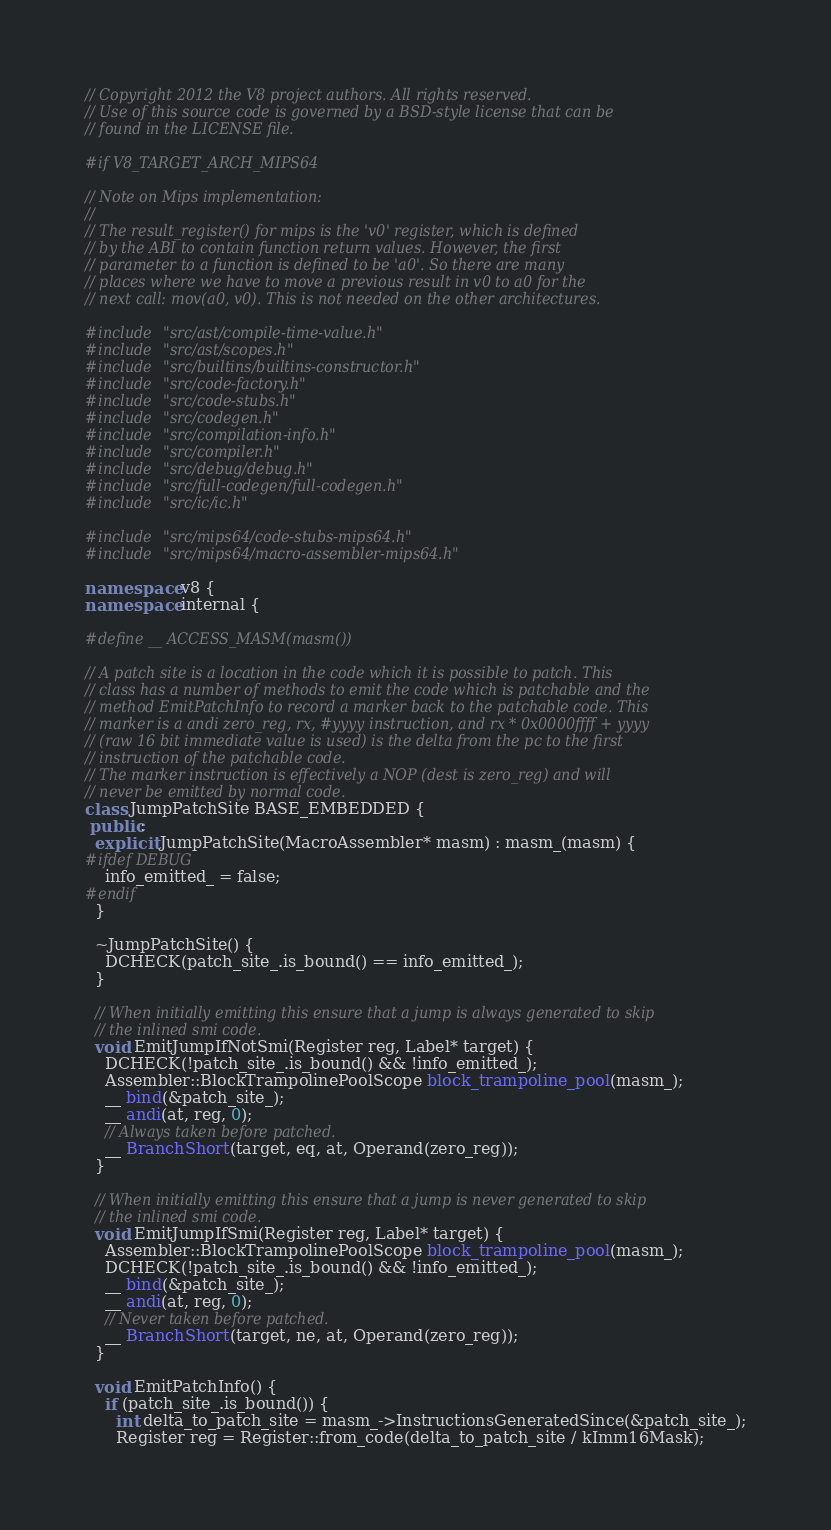Convert code to text. <code><loc_0><loc_0><loc_500><loc_500><_C++_>// Copyright 2012 the V8 project authors. All rights reserved.
// Use of this source code is governed by a BSD-style license that can be
// found in the LICENSE file.

#if V8_TARGET_ARCH_MIPS64

// Note on Mips implementation:
//
// The result_register() for mips is the 'v0' register, which is defined
// by the ABI to contain function return values. However, the first
// parameter to a function is defined to be 'a0'. So there are many
// places where we have to move a previous result in v0 to a0 for the
// next call: mov(a0, v0). This is not needed on the other architectures.

#include "src/ast/compile-time-value.h"
#include "src/ast/scopes.h"
#include "src/builtins/builtins-constructor.h"
#include "src/code-factory.h"
#include "src/code-stubs.h"
#include "src/codegen.h"
#include "src/compilation-info.h"
#include "src/compiler.h"
#include "src/debug/debug.h"
#include "src/full-codegen/full-codegen.h"
#include "src/ic/ic.h"

#include "src/mips64/code-stubs-mips64.h"
#include "src/mips64/macro-assembler-mips64.h"

namespace v8 {
namespace internal {

#define __ ACCESS_MASM(masm())

// A patch site is a location in the code which it is possible to patch. This
// class has a number of methods to emit the code which is patchable and the
// method EmitPatchInfo to record a marker back to the patchable code. This
// marker is a andi zero_reg, rx, #yyyy instruction, and rx * 0x0000ffff + yyyy
// (raw 16 bit immediate value is used) is the delta from the pc to the first
// instruction of the patchable code.
// The marker instruction is effectively a NOP (dest is zero_reg) and will
// never be emitted by normal code.
class JumpPatchSite BASE_EMBEDDED {
 public:
  explicit JumpPatchSite(MacroAssembler* masm) : masm_(masm) {
#ifdef DEBUG
    info_emitted_ = false;
#endif
  }

  ~JumpPatchSite() {
    DCHECK(patch_site_.is_bound() == info_emitted_);
  }

  // When initially emitting this ensure that a jump is always generated to skip
  // the inlined smi code.
  void EmitJumpIfNotSmi(Register reg, Label* target) {
    DCHECK(!patch_site_.is_bound() && !info_emitted_);
    Assembler::BlockTrampolinePoolScope block_trampoline_pool(masm_);
    __ bind(&patch_site_);
    __ andi(at, reg, 0);
    // Always taken before patched.
    __ BranchShort(target, eq, at, Operand(zero_reg));
  }

  // When initially emitting this ensure that a jump is never generated to skip
  // the inlined smi code.
  void EmitJumpIfSmi(Register reg, Label* target) {
    Assembler::BlockTrampolinePoolScope block_trampoline_pool(masm_);
    DCHECK(!patch_site_.is_bound() && !info_emitted_);
    __ bind(&patch_site_);
    __ andi(at, reg, 0);
    // Never taken before patched.
    __ BranchShort(target, ne, at, Operand(zero_reg));
  }

  void EmitPatchInfo() {
    if (patch_site_.is_bound()) {
      int delta_to_patch_site = masm_->InstructionsGeneratedSince(&patch_site_);
      Register reg = Register::from_code(delta_to_patch_site / kImm16Mask);</code> 